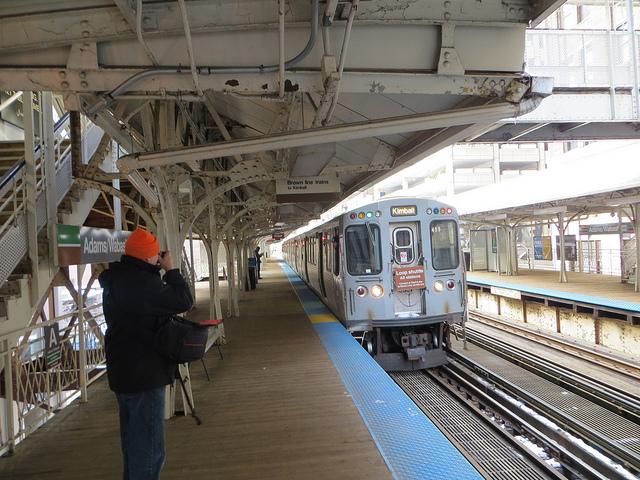What is he doing?
Answer briefly. Taking picture. Is the man taking a picture of the train?
Keep it brief. Yes. Why is he wearing a knit hat?
Give a very brief answer. Cold. 